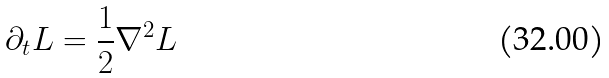Convert formula to latex. <formula><loc_0><loc_0><loc_500><loc_500>\partial _ { t } L = \frac { 1 } { 2 } \nabla ^ { 2 } L</formula> 